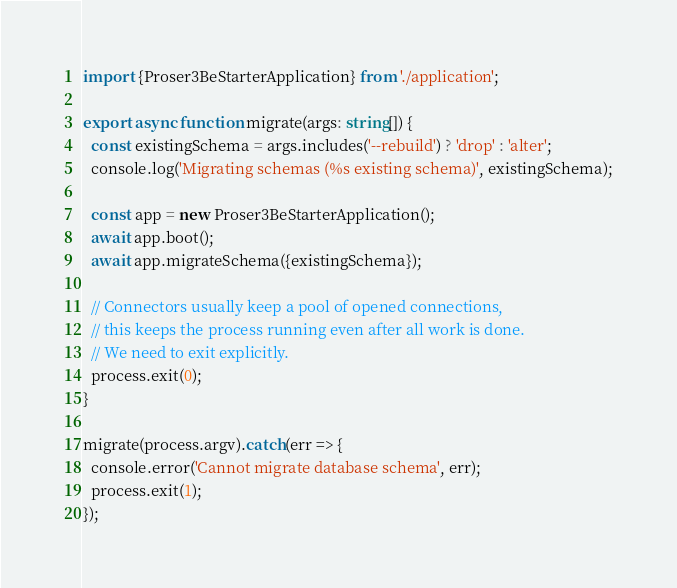<code> <loc_0><loc_0><loc_500><loc_500><_TypeScript_>import {Proser3BeStarterApplication} from './application';

export async function migrate(args: string[]) {
  const existingSchema = args.includes('--rebuild') ? 'drop' : 'alter';
  console.log('Migrating schemas (%s existing schema)', existingSchema);

  const app = new Proser3BeStarterApplication();
  await app.boot();
  await app.migrateSchema({existingSchema});

  // Connectors usually keep a pool of opened connections,
  // this keeps the process running even after all work is done.
  // We need to exit explicitly.
  process.exit(0);
}

migrate(process.argv).catch(err => {
  console.error('Cannot migrate database schema', err);
  process.exit(1);
});
</code> 